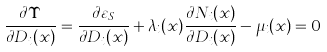Convert formula to latex. <formula><loc_0><loc_0><loc_500><loc_500>\frac { \partial \Upsilon } { \partial D _ { i } ( x ) } = \frac { \partial \varepsilon _ { S } } { \partial D _ { i } ( x ) } + \lambda _ { i } ( x ) \frac { \partial N _ { i } ( x ) } { \partial D _ { i } ( x ) } - \mu _ { i } ( x ) = 0</formula> 